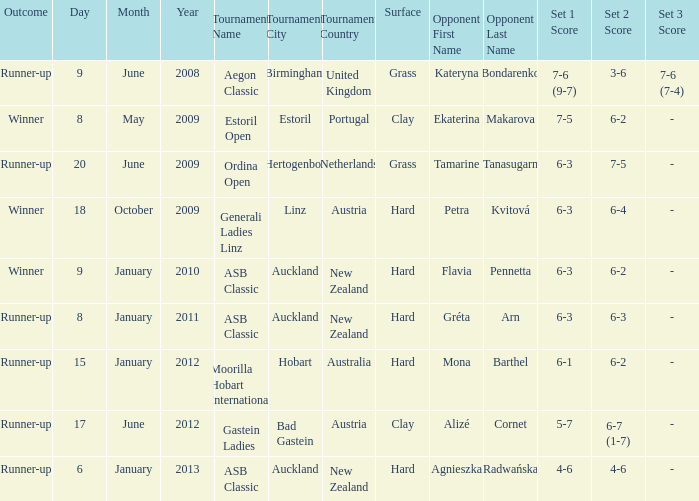What was the score in the tournament against Ekaterina Makarova? 7–5, 6–2. Could you parse the entire table as a dict? {'header': ['Outcome', 'Day', 'Month', 'Year', 'Tournament Name', 'Tournament City', 'Tournament Country', 'Surface', 'Opponent First Name', 'Opponent Last Name', 'Set 1 Score', 'Set 2 Score', 'Set 3 Score'], 'rows': [['Runner-up', '9', 'June', '2008', 'Aegon Classic', 'Birmingham', 'United Kingdom', 'Grass', 'Kateryna', 'Bondarenko', '7-6 (9-7)', '3-6', '7-6 (7-4)'], ['Winner', '8', 'May', '2009', 'Estoril Open', 'Estoril', 'Portugal', 'Clay', 'Ekaterina', 'Makarova', '7-5', '6-2', '-'], ['Runner-up', '20', 'June', '2009', 'Ordina Open', "'s-Hertogenbosch", 'Netherlands', 'Grass', 'Tamarine', 'Tanasugarn', '6-3', '7-5', '-'], ['Winner', '18', 'October', '2009', 'Generali Ladies Linz', 'Linz', 'Austria', 'Hard', 'Petra', 'Kvitová', '6-3', '6-4', '-'], ['Winner', '9', 'January', '2010', 'ASB Classic', 'Auckland', 'New Zealand', 'Hard', 'Flavia', 'Pennetta', '6-3', '6-2', '-'], ['Runner-up', '8', 'January', '2011', 'ASB Classic', 'Auckland', 'New Zealand', 'Hard', 'Gréta', 'Arn', '6-3', '6-3', '-'], ['Runner-up', '15', 'January', '2012', 'Moorilla Hobart International', 'Hobart', 'Australia', 'Hard', 'Mona', 'Barthel', '6-1', '6-2', '-'], ['Runner-up', '17', 'June', '2012', 'Gastein Ladies', 'Bad Gastein', 'Austria', 'Clay', 'Alizé', 'Cornet', '5-7', '6-7 (1-7)', '-'], ['Runner-up', '6', 'January', '2013', 'ASB Classic', 'Auckland', 'New Zealand', 'Hard', 'Agnieszka', 'Radwańska', '4-6', '4-6', '-']]} 